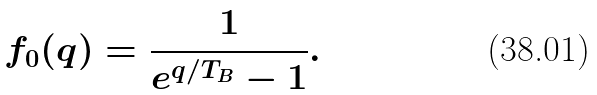<formula> <loc_0><loc_0><loc_500><loc_500>f _ { 0 } ( q ) = \frac { 1 } { e ^ { q / T _ { B } } - 1 } .</formula> 